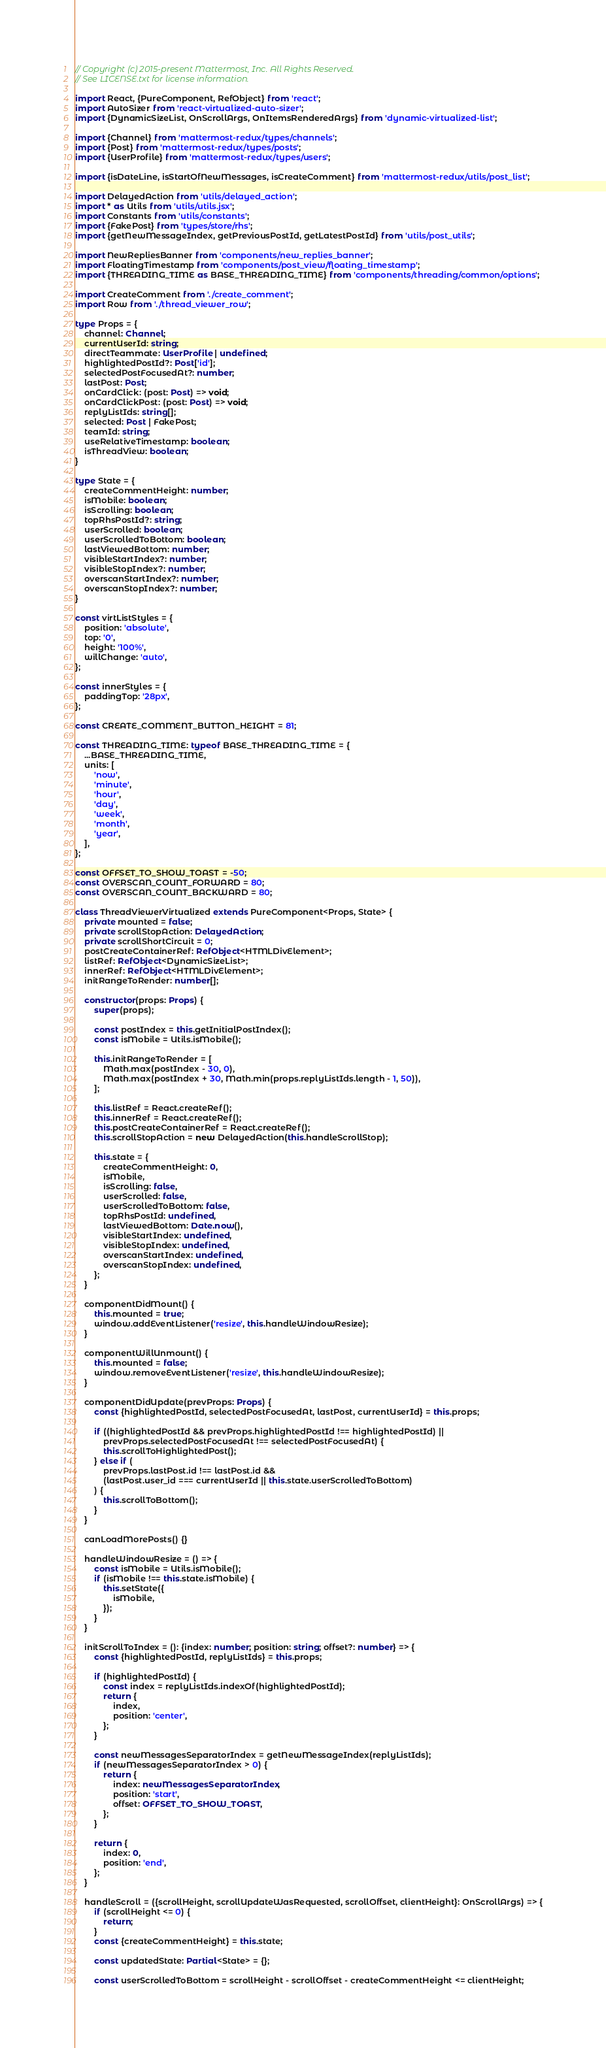Convert code to text. <code><loc_0><loc_0><loc_500><loc_500><_TypeScript_>// Copyright (c) 2015-present Mattermost, Inc. All Rights Reserved.
// See LICENSE.txt for license information.

import React, {PureComponent, RefObject} from 'react';
import AutoSizer from 'react-virtualized-auto-sizer';
import {DynamicSizeList, OnScrollArgs, OnItemsRenderedArgs} from 'dynamic-virtualized-list';

import {Channel} from 'mattermost-redux/types/channels';
import {Post} from 'mattermost-redux/types/posts';
import {UserProfile} from 'mattermost-redux/types/users';

import {isDateLine, isStartOfNewMessages, isCreateComment} from 'mattermost-redux/utils/post_list';

import DelayedAction from 'utils/delayed_action';
import * as Utils from 'utils/utils.jsx';
import Constants from 'utils/constants';
import {FakePost} from 'types/store/rhs';
import {getNewMessageIndex, getPreviousPostId, getLatestPostId} from 'utils/post_utils';

import NewRepliesBanner from 'components/new_replies_banner';
import FloatingTimestamp from 'components/post_view/floating_timestamp';
import {THREADING_TIME as BASE_THREADING_TIME} from 'components/threading/common/options';

import CreateComment from './create_comment';
import Row from './thread_viewer_row';

type Props = {
    channel: Channel;
    currentUserId: string;
    directTeammate: UserProfile | undefined;
    highlightedPostId?: Post['id'];
    selectedPostFocusedAt?: number;
    lastPost: Post;
    onCardClick: (post: Post) => void;
    onCardClickPost: (post: Post) => void;
    replyListIds: string[];
    selected: Post | FakePost;
    teamId: string;
    useRelativeTimestamp: boolean;
    isThreadView: boolean;
}

type State = {
    createCommentHeight: number;
    isMobile: boolean;
    isScrolling: boolean;
    topRhsPostId?: string;
    userScrolled: boolean;
    userScrolledToBottom: boolean;
    lastViewedBottom: number;
    visibleStartIndex?: number;
    visibleStopIndex?: number;
    overscanStartIndex?: number;
    overscanStopIndex?: number;
}

const virtListStyles = {
    position: 'absolute',
    top: '0',
    height: '100%',
    willChange: 'auto',
};

const innerStyles = {
    paddingTop: '28px',
};

const CREATE_COMMENT_BUTTON_HEIGHT = 81;

const THREADING_TIME: typeof BASE_THREADING_TIME = {
    ...BASE_THREADING_TIME,
    units: [
        'now',
        'minute',
        'hour',
        'day',
        'week',
        'month',
        'year',
    ],
};

const OFFSET_TO_SHOW_TOAST = -50;
const OVERSCAN_COUNT_FORWARD = 80;
const OVERSCAN_COUNT_BACKWARD = 80;

class ThreadViewerVirtualized extends PureComponent<Props, State> {
    private mounted = false;
    private scrollStopAction: DelayedAction;
    private scrollShortCircuit = 0;
    postCreateContainerRef: RefObject<HTMLDivElement>;
    listRef: RefObject<DynamicSizeList>;
    innerRef: RefObject<HTMLDivElement>;
    initRangeToRender: number[];

    constructor(props: Props) {
        super(props);

        const postIndex = this.getInitialPostIndex();
        const isMobile = Utils.isMobile();

        this.initRangeToRender = [
            Math.max(postIndex - 30, 0),
            Math.max(postIndex + 30, Math.min(props.replyListIds.length - 1, 50)),
        ];

        this.listRef = React.createRef();
        this.innerRef = React.createRef();
        this.postCreateContainerRef = React.createRef();
        this.scrollStopAction = new DelayedAction(this.handleScrollStop);

        this.state = {
            createCommentHeight: 0,
            isMobile,
            isScrolling: false,
            userScrolled: false,
            userScrolledToBottom: false,
            topRhsPostId: undefined,
            lastViewedBottom: Date.now(),
            visibleStartIndex: undefined,
            visibleStopIndex: undefined,
            overscanStartIndex: undefined,
            overscanStopIndex: undefined,
        };
    }

    componentDidMount() {
        this.mounted = true;
        window.addEventListener('resize', this.handleWindowResize);
    }

    componentWillUnmount() {
        this.mounted = false;
        window.removeEventListener('resize', this.handleWindowResize);
    }

    componentDidUpdate(prevProps: Props) {
        const {highlightedPostId, selectedPostFocusedAt, lastPost, currentUserId} = this.props;

        if ((highlightedPostId && prevProps.highlightedPostId !== highlightedPostId) ||
            prevProps.selectedPostFocusedAt !== selectedPostFocusedAt) {
            this.scrollToHighlightedPost();
        } else if (
            prevProps.lastPost.id !== lastPost.id &&
            (lastPost.user_id === currentUserId || this.state.userScrolledToBottom)
        ) {
            this.scrollToBottom();
        }
    }

    canLoadMorePosts() {}

    handleWindowResize = () => {
        const isMobile = Utils.isMobile();
        if (isMobile !== this.state.isMobile) {
            this.setState({
                isMobile,
            });
        }
    }

    initScrollToIndex = (): {index: number; position: string; offset?: number} => {
        const {highlightedPostId, replyListIds} = this.props;

        if (highlightedPostId) {
            const index = replyListIds.indexOf(highlightedPostId);
            return {
                index,
                position: 'center',
            };
        }

        const newMessagesSeparatorIndex = getNewMessageIndex(replyListIds);
        if (newMessagesSeparatorIndex > 0) {
            return {
                index: newMessagesSeparatorIndex,
                position: 'start',
                offset: OFFSET_TO_SHOW_TOAST,
            };
        }

        return {
            index: 0,
            position: 'end',
        };
    }

    handleScroll = ({scrollHeight, scrollUpdateWasRequested, scrollOffset, clientHeight}: OnScrollArgs) => {
        if (scrollHeight <= 0) {
            return;
        }
        const {createCommentHeight} = this.state;

        const updatedState: Partial<State> = {};

        const userScrolledToBottom = scrollHeight - scrollOffset - createCommentHeight <= clientHeight;
</code> 